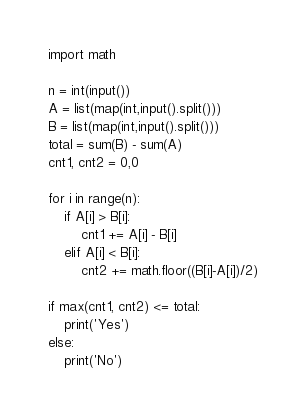Convert code to text. <code><loc_0><loc_0><loc_500><loc_500><_Python_>import math

n = int(input())
A = list(map(int,input().split()))
B = list(map(int,input().split()))
total = sum(B) - sum(A)
cnt1, cnt2 = 0,0

for i in range(n):
    if A[i] > B[i]:
        cnt1 += A[i] - B[i]
    elif A[i] < B[i]:
        cnt2 += math.floor((B[i]-A[i])/2)

if max(cnt1, cnt2) <= total:
    print('Yes')
else:
    print('No')</code> 